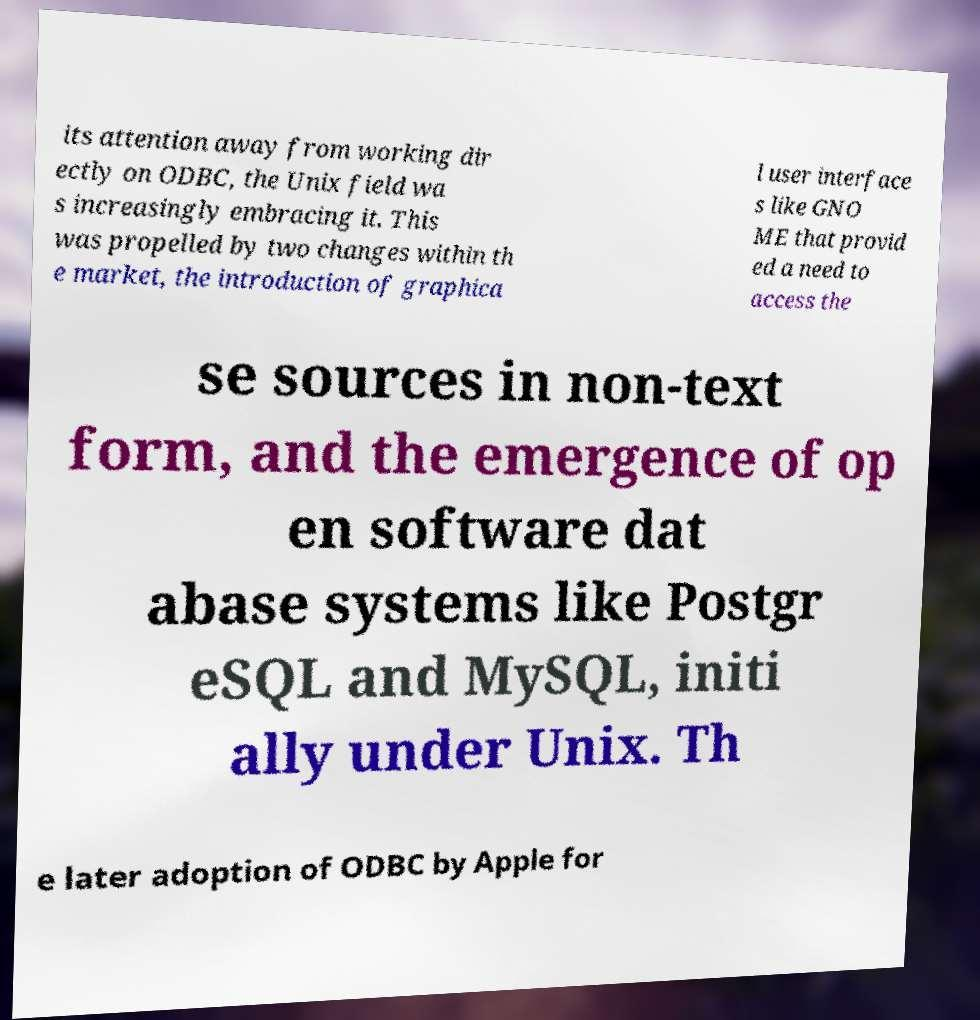Can you accurately transcribe the text from the provided image for me? its attention away from working dir ectly on ODBC, the Unix field wa s increasingly embracing it. This was propelled by two changes within th e market, the introduction of graphica l user interface s like GNO ME that provid ed a need to access the se sources in non-text form, and the emergence of op en software dat abase systems like Postgr eSQL and MySQL, initi ally under Unix. Th e later adoption of ODBC by Apple for 